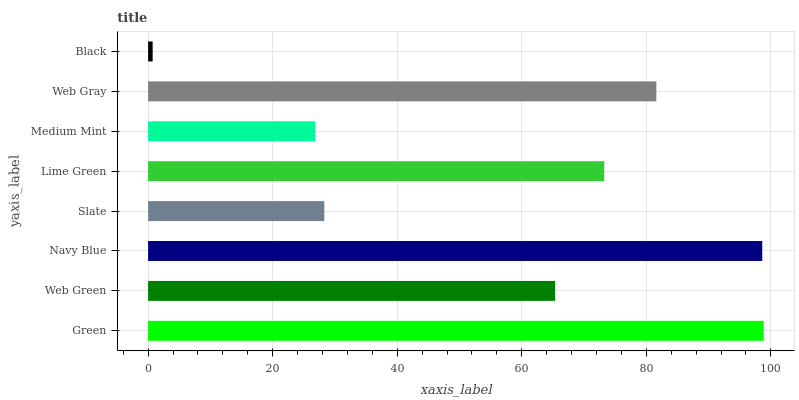Is Black the minimum?
Answer yes or no. Yes. Is Green the maximum?
Answer yes or no. Yes. Is Web Green the minimum?
Answer yes or no. No. Is Web Green the maximum?
Answer yes or no. No. Is Green greater than Web Green?
Answer yes or no. Yes. Is Web Green less than Green?
Answer yes or no. Yes. Is Web Green greater than Green?
Answer yes or no. No. Is Green less than Web Green?
Answer yes or no. No. Is Lime Green the high median?
Answer yes or no. Yes. Is Web Green the low median?
Answer yes or no. Yes. Is Black the high median?
Answer yes or no. No. Is Slate the low median?
Answer yes or no. No. 